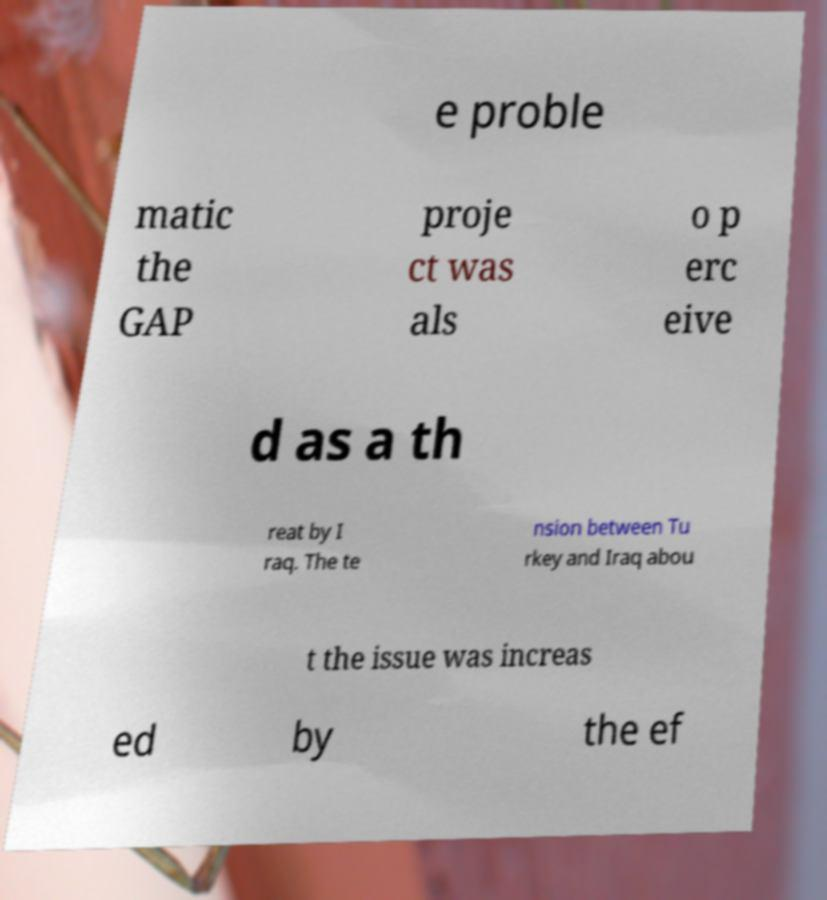Please read and relay the text visible in this image. What does it say? e proble matic the GAP proje ct was als o p erc eive d as a th reat by I raq. The te nsion between Tu rkey and Iraq abou t the issue was increas ed by the ef 